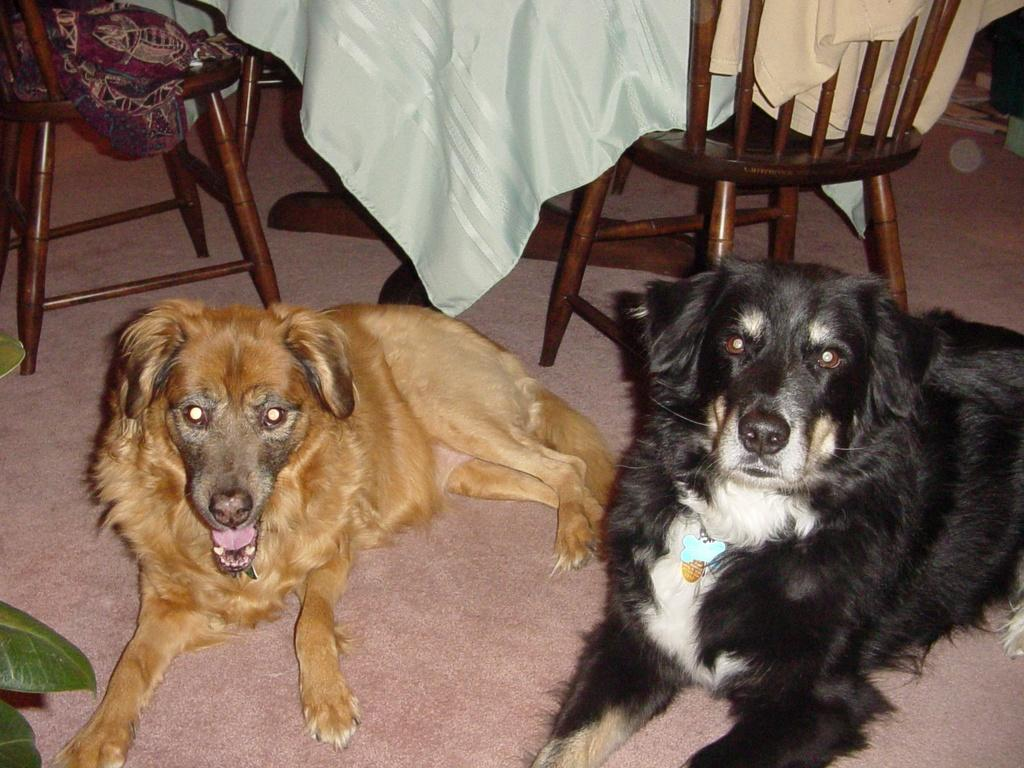How many dogs are present in the image? There are 2 dogs in the image. What type of furniture can be seen in the image? There are chairs in the image. What else is visible in the image besides the dogs and chairs? There are clothes in the image. What type of coat is the cabbage wearing in the image? There is no cabbage or coat present in the image. How does the sail affect the dogs' behavior in the image? There is no sail present in the image, so it cannot affect the dogs' behavior. 